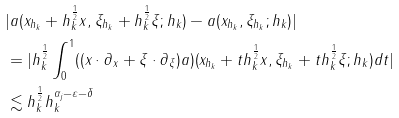<formula> <loc_0><loc_0><loc_500><loc_500>& | a ( x _ { h _ { k } } + h _ { k } ^ { \frac { 1 } { 2 } } x , \xi _ { h _ { k } } + h _ { k } ^ { \frac { 1 } { 2 } } \xi ; h _ { k } ) - a ( x _ { h _ { k } } , \xi _ { h _ { k } } ; h _ { k } ) | \\ & = | h _ { k } ^ { \frac { 1 } { 2 } } \int _ { 0 } ^ { 1 } ( ( x \cdot \partial _ { x } + \xi \cdot \partial _ { \xi } ) a ) ( x _ { h _ { k } } + t h _ { k } ^ { \frac { 1 } { 2 } } x , \xi _ { h _ { k } } + t h _ { k } ^ { \frac { 1 } { 2 } } \xi ; h _ { k } ) d t | \\ & \lesssim h _ { k } ^ { \frac { 1 } { 2 } } h _ { k } ^ { \alpha _ { j } - \varepsilon - \delta }</formula> 